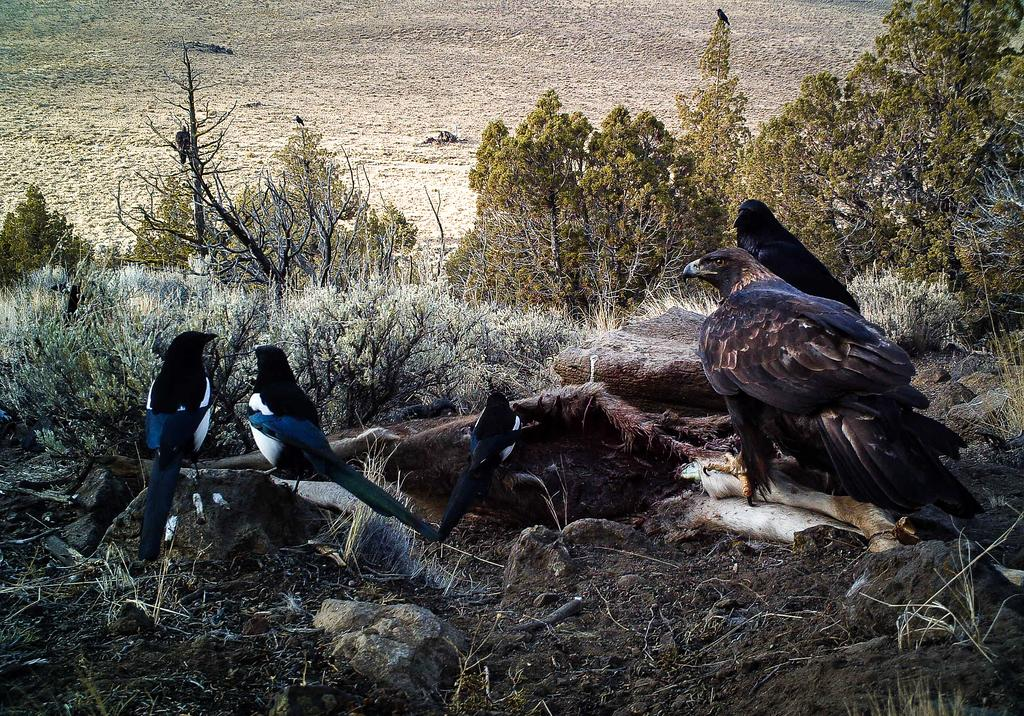What type of vegetation can be seen in the image? There are trees in the image. What animals are present in the image? There are birds in the middle of the image. What other type of plant life can be seen on the left side of the image? There are plants on the left side of the image. Can you see a cap floating down the stream in the image? There is no stream or cap present in the image. 